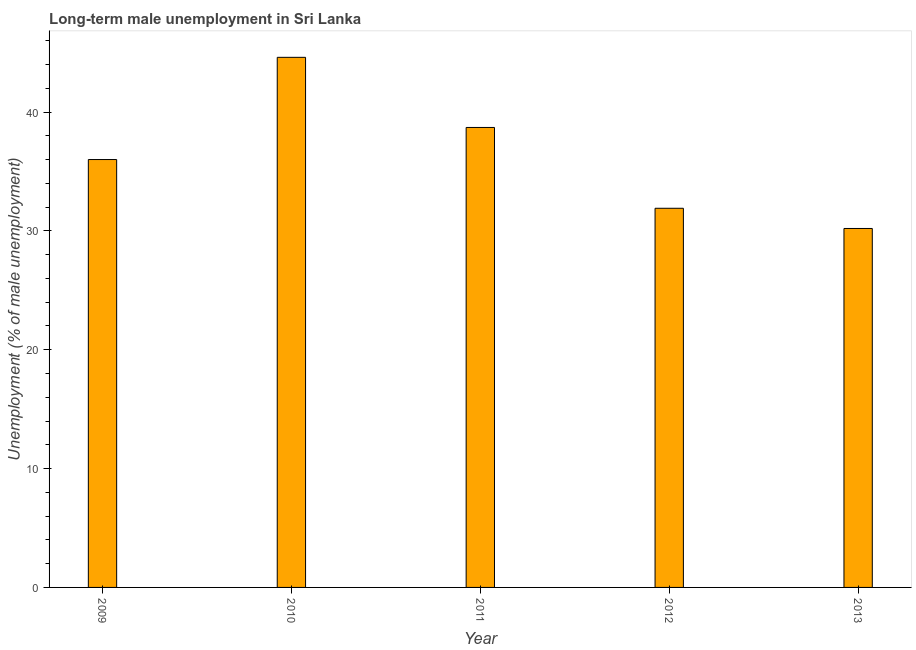Does the graph contain any zero values?
Offer a terse response. No. What is the title of the graph?
Offer a very short reply. Long-term male unemployment in Sri Lanka. What is the label or title of the X-axis?
Your answer should be compact. Year. What is the label or title of the Y-axis?
Keep it short and to the point. Unemployment (% of male unemployment). What is the long-term male unemployment in 2011?
Offer a very short reply. 38.7. Across all years, what is the maximum long-term male unemployment?
Your answer should be compact. 44.6. Across all years, what is the minimum long-term male unemployment?
Your answer should be very brief. 30.2. In which year was the long-term male unemployment maximum?
Provide a short and direct response. 2010. What is the sum of the long-term male unemployment?
Ensure brevity in your answer.  181.4. What is the difference between the long-term male unemployment in 2009 and 2013?
Your answer should be very brief. 5.8. What is the average long-term male unemployment per year?
Give a very brief answer. 36.28. What is the ratio of the long-term male unemployment in 2012 to that in 2013?
Your answer should be compact. 1.06. Is the long-term male unemployment in 2009 less than that in 2011?
Your answer should be compact. Yes. Is the difference between the long-term male unemployment in 2010 and 2011 greater than the difference between any two years?
Provide a succinct answer. No. Is the sum of the long-term male unemployment in 2009 and 2011 greater than the maximum long-term male unemployment across all years?
Offer a very short reply. Yes. In how many years, is the long-term male unemployment greater than the average long-term male unemployment taken over all years?
Keep it short and to the point. 2. How many bars are there?
Give a very brief answer. 5. Are all the bars in the graph horizontal?
Provide a short and direct response. No. What is the difference between two consecutive major ticks on the Y-axis?
Your answer should be compact. 10. Are the values on the major ticks of Y-axis written in scientific E-notation?
Offer a terse response. No. What is the Unemployment (% of male unemployment) in 2010?
Provide a succinct answer. 44.6. What is the Unemployment (% of male unemployment) in 2011?
Your response must be concise. 38.7. What is the Unemployment (% of male unemployment) in 2012?
Your response must be concise. 31.9. What is the Unemployment (% of male unemployment) in 2013?
Ensure brevity in your answer.  30.2. What is the difference between the Unemployment (% of male unemployment) in 2009 and 2010?
Ensure brevity in your answer.  -8.6. What is the difference between the Unemployment (% of male unemployment) in 2009 and 2011?
Your answer should be very brief. -2.7. What is the difference between the Unemployment (% of male unemployment) in 2009 and 2012?
Ensure brevity in your answer.  4.1. What is the difference between the Unemployment (% of male unemployment) in 2009 and 2013?
Provide a succinct answer. 5.8. What is the difference between the Unemployment (% of male unemployment) in 2010 and 2013?
Your answer should be compact. 14.4. What is the difference between the Unemployment (% of male unemployment) in 2011 and 2012?
Make the answer very short. 6.8. What is the ratio of the Unemployment (% of male unemployment) in 2009 to that in 2010?
Your response must be concise. 0.81. What is the ratio of the Unemployment (% of male unemployment) in 2009 to that in 2012?
Ensure brevity in your answer.  1.13. What is the ratio of the Unemployment (% of male unemployment) in 2009 to that in 2013?
Offer a terse response. 1.19. What is the ratio of the Unemployment (% of male unemployment) in 2010 to that in 2011?
Your answer should be very brief. 1.15. What is the ratio of the Unemployment (% of male unemployment) in 2010 to that in 2012?
Give a very brief answer. 1.4. What is the ratio of the Unemployment (% of male unemployment) in 2010 to that in 2013?
Offer a terse response. 1.48. What is the ratio of the Unemployment (% of male unemployment) in 2011 to that in 2012?
Make the answer very short. 1.21. What is the ratio of the Unemployment (% of male unemployment) in 2011 to that in 2013?
Ensure brevity in your answer.  1.28. What is the ratio of the Unemployment (% of male unemployment) in 2012 to that in 2013?
Your answer should be very brief. 1.06. 